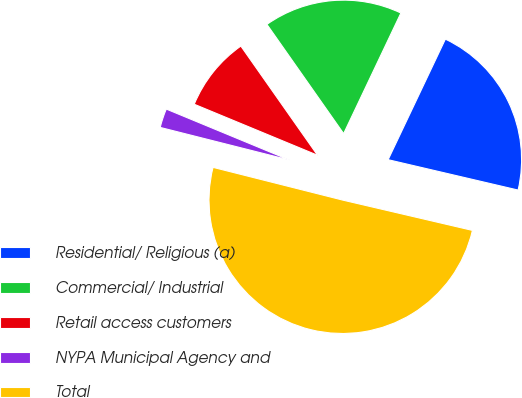Convert chart to OTSL. <chart><loc_0><loc_0><loc_500><loc_500><pie_chart><fcel>Residential/ Religious (a)<fcel>Commercial/ Industrial<fcel>Retail access customers<fcel>NYPA Municipal Agency and<fcel>Total<nl><fcel>21.6%<fcel>16.8%<fcel>9.01%<fcel>2.31%<fcel>50.28%<nl></chart> 